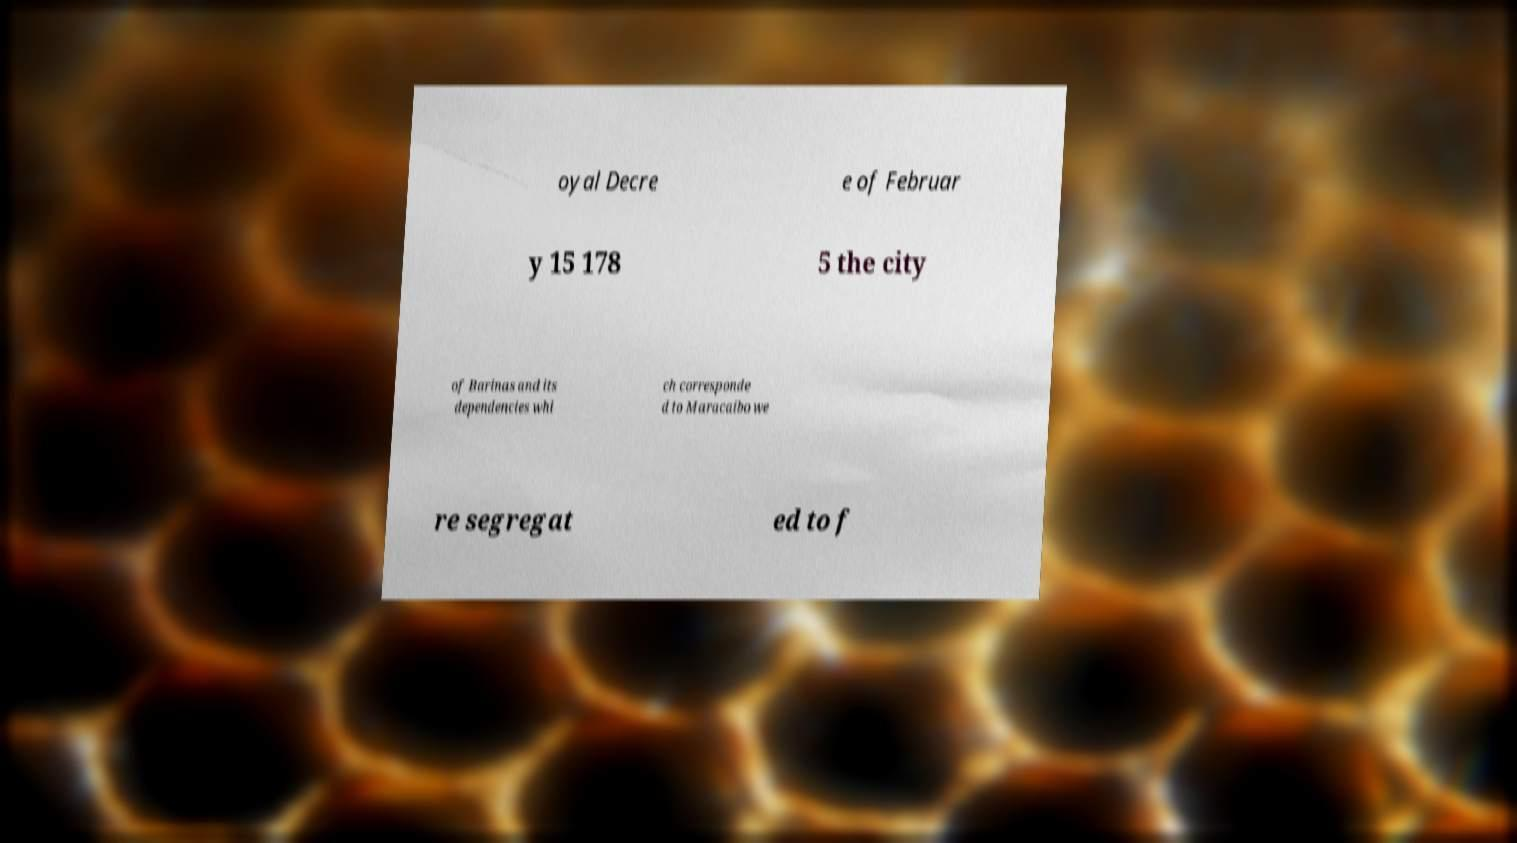Could you assist in decoding the text presented in this image and type it out clearly? oyal Decre e of Februar y 15 178 5 the city of Barinas and its dependencies whi ch corresponde d to Maracaibo we re segregat ed to f 